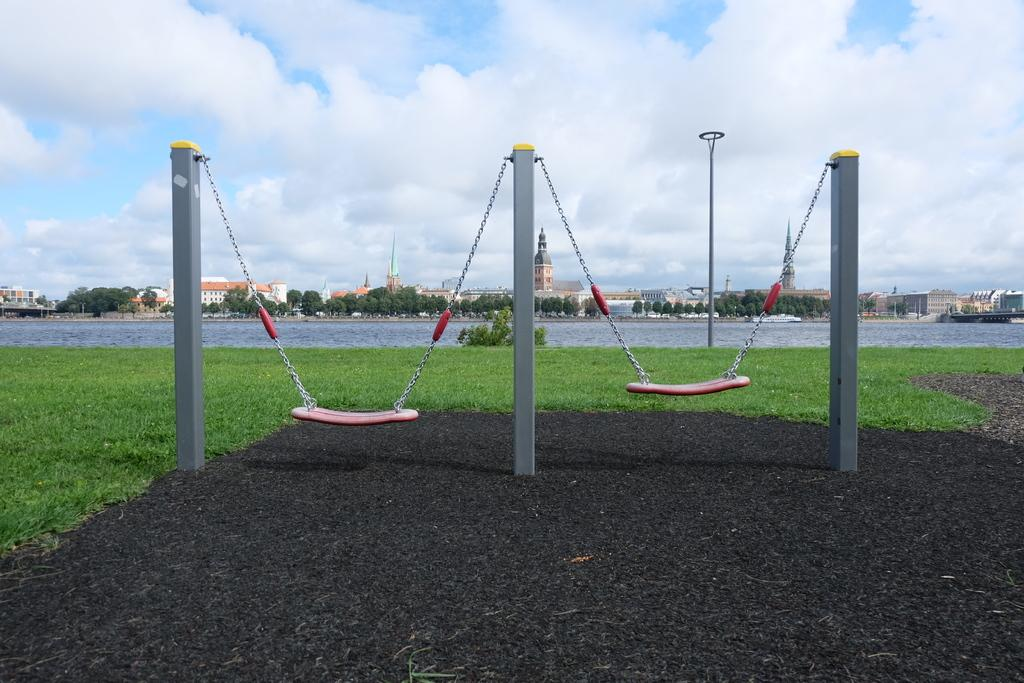What type of surface is visible in the image? There is a grass surface in the image. How many poles can be seen in the image? There are three poles in the image. What can be seen in the distance behind the poles? There is a water surface, trees, buildings, and the sky visible in the background of the image. What is the condition of the sky in the image? The sky is visible in the background of the image, and clouds are present. What type of pest can be seen crawling on the grass in the image? There is no pest visible in the image; it only shows a grass surface, poles, and the background. --- Facts: 1. There is a person sitting on a chair in the image. 2. The person is holding a book. 3. The book has a red cover. 4. There is a table next to the chair. 5. There is a lamp on the table. 6. The room has a wooden floor. Absurd Topics: parrot, sand, bicycle Conversation: What is the person in the image doing? The person is sitting on a chair in the image. What is the person holding in the image? The person is holding a book in the image. What color is the book's cover? The book has a red cover. What is located next to the chair? There is a table next to the chair. What is on the table? There is a lamp on the table. What type of flooring is present in the room? The room has a wooden floor. Reasoning: Let's think step by step in order to produce the conversation. We start by identifying the main subject in the image, which is the person sitting on a chair. Then, we describe what the person is holding, which is a book with a red cover. Next, we mention the table and lamp, which are nearby objects. Finally, we describe the flooring to provide more detail about the room's appearance. Absurd Question/Answer: What type of sand can be seen on the floor in the image? There is no sand present on the floor in the image; it has a wooden floor. Can you tell me how many bicycles are in the image? There are no bicycles present in the image. 